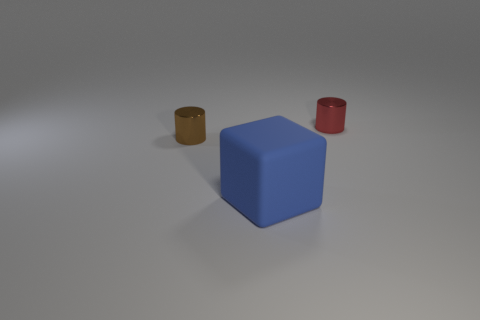Add 2 big blue objects. How many objects exist? 5 Subtract all cylinders. How many objects are left? 1 Subtract 1 red cylinders. How many objects are left? 2 Subtract all large blue metallic cylinders. Subtract all tiny red things. How many objects are left? 2 Add 3 red cylinders. How many red cylinders are left? 4 Add 3 blocks. How many blocks exist? 4 